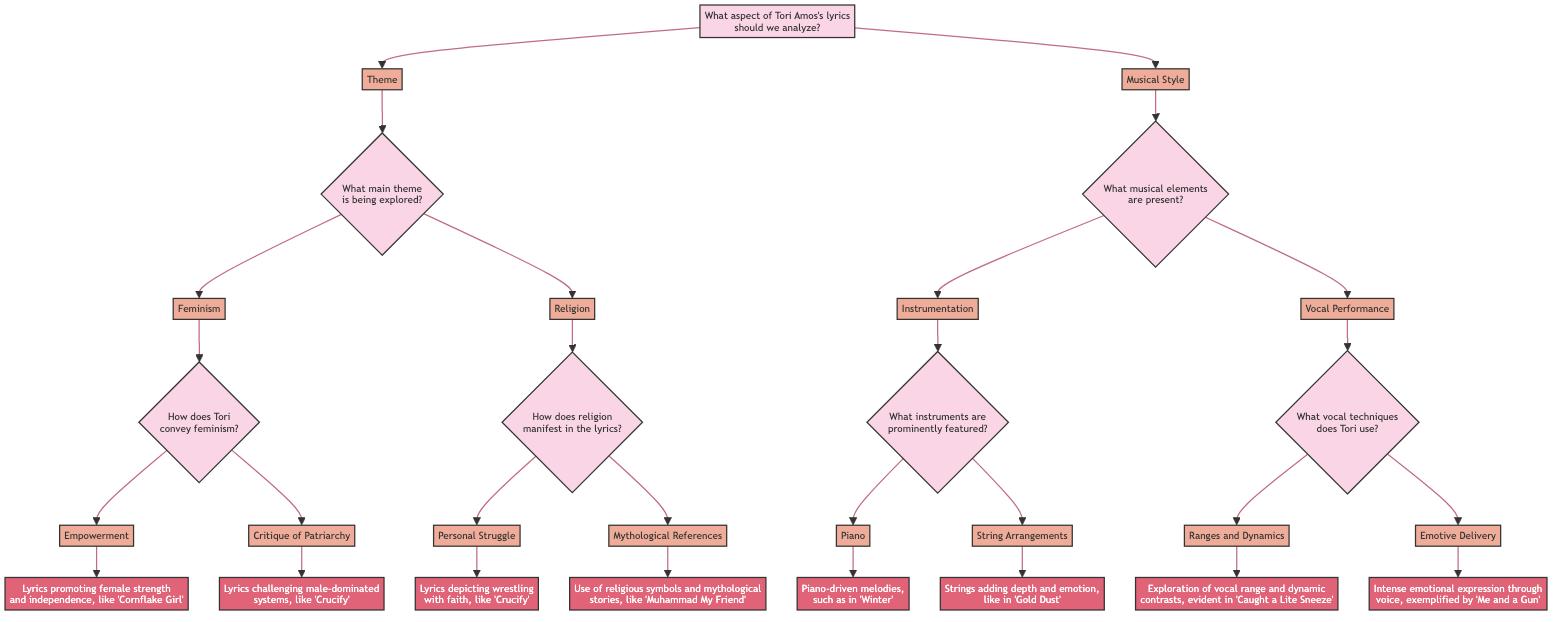What is the main aspect to analyze in Tori Amos's lyrics? The diagram's root node states, "What aspect of Tori Amos's lyrics should we analyze?" which refers to the two primary categories: Theme and Musical Style. Thus, the answer is the aspect mentioned: "Theme" or "Musical Style" can both be accepted.
Answer: Theme or Musical Style How many main themes are explored in Tori Amos's lyrics according to the diagram? The diagram lists two main themes under the options following the root question: Feminism and Religion. Counting these options gives us a total of two main themes.
Answer: 2 What question follows the theme "Feminism"? After selecting "Feminism," the diagram presents the question "How does Tori convey feminism?" as the next step in the decision tree. This indicates the exploration of how this theme is represented in her lyrics.
Answer: How does Tori convey feminism? Which song illustrates "Empowerment" in Tori Amos's lyrics? In the diagram, "Empowerment" is associated with the detail "Lyrics promoting female strength and independence, like 'Cornflake Girl.'" This song effectively showcases the theme of empowerment within her music.
Answer: Cornflake Girl What are the two main categories under "Musical Style"? The "Musical Style" option branches out to two categories: Instrumentation and Vocal Performance. This shows the primary areas in which her musical style can be analyzed.
Answer: Instrumentation and Vocal Performance Which song exemplifies "Intense emotional expression through voice"? According to the diagram, "Intense emotional expression through voice" is linked to the detail "exemplified by 'Me and a Gun.'" This song is highlighted as a representation of emotive delivery in her vocal performance.
Answer: Me and a Gun How many questions are associated with the theme of religion? Under the theme of religion, there are two subsequent questions shown: "How does religion manifest in the lyrics?" This indicates that there are two different angles from which to explore this theme.
Answer: 2 What musical element is primarily featured in "Winter"? The diagram indicates that under the category of Instrumentation, "Piano" is highlighted with the detail "Piano-driven melodies, such as in 'Winter.'" This shows that the piano is a significant musical element in that song.
Answer: Piano Which option corresponds to the critique of patriarchy in Tori Amos's lyrics? The diagram shows that "Critique of Patriarchy" is an option under the theme of Feminism, which indicates Tori's lyrical focus on challenging male-dominated systems. The specific detail associated with this option is, "Lyrics challenging male-dominated systems, like 'Crucify.'"
Answer: Critique of Patriarchy 